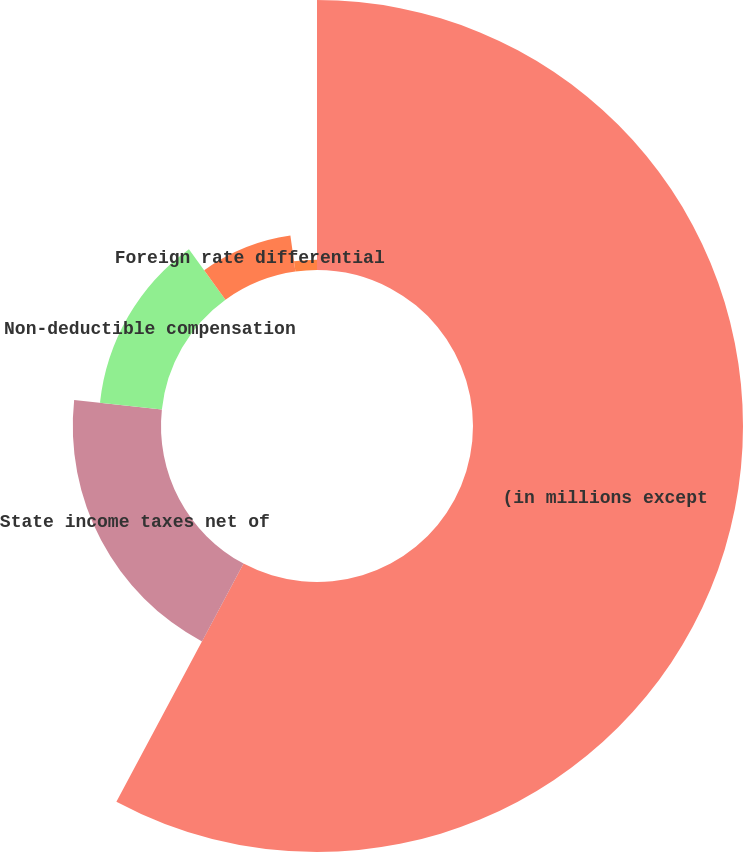Convert chart. <chart><loc_0><loc_0><loc_500><loc_500><pie_chart><fcel>(in millions except<fcel>State income taxes net of<fcel>Non-deductible compensation<fcel>Foreign rate differential<fcel>Other net<nl><fcel>57.81%<fcel>18.89%<fcel>13.33%<fcel>7.77%<fcel>2.21%<nl></chart> 